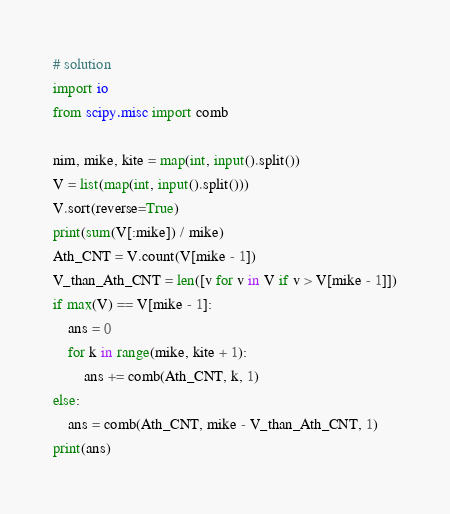<code> <loc_0><loc_0><loc_500><loc_500><_Python_># solution
import io
from scipy.misc import comb

nim, mike, kite = map(int, input().split())
V = list(map(int, input().split()))
V.sort(reverse=True)
print(sum(V[:mike]) / mike)
Ath_CNT = V.count(V[mike - 1])
V_than_Ath_CNT = len([v for v in V if v > V[mike - 1]])
if max(V) == V[mike - 1]:
    ans = 0
    for k in range(mike, kite + 1):
        ans += comb(Ath_CNT, k, 1)
else:
    ans = comb(Ath_CNT, mike - V_than_Ath_CNT, 1)
print(ans)
</code> 